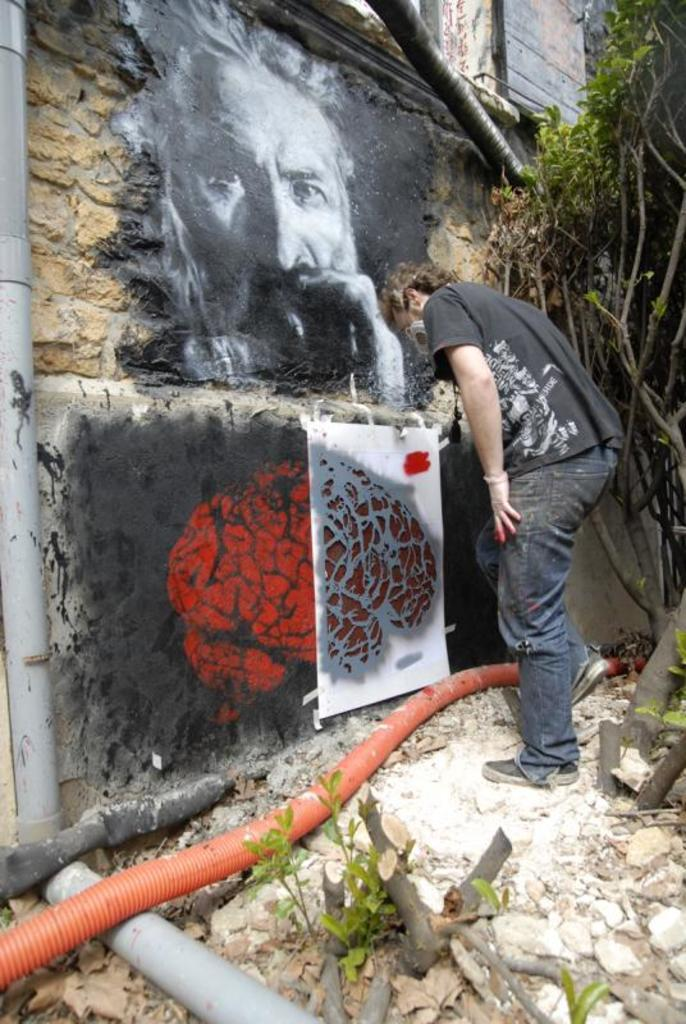What is the main subject of the image? There is a man standing in the center of the image. What is the man doing in the image? The man is painting on a wall. What can be seen on the right side of the image? There is a tree on the right side of the image. What else is visible at the bottom of the image? Pipes are visible at the bottom of the image. What type of bun is the man holding in the image? There is no bun present in the image; the man is holding a paintbrush while painting on a wall. Can you tell me how many doors are visible in the image? There are no doors visible in the image. 